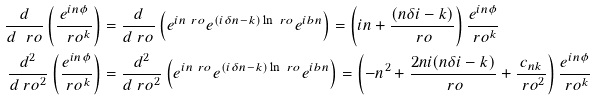Convert formula to latex. <formula><loc_0><loc_0><loc_500><loc_500>\frac { d } { d \ r o } \left ( \frac { e ^ { i n \phi } } { \ r o ^ { k } } \right ) & = \frac { d } { d \ r o } \left ( e ^ { i n \ r o } e ^ { ( i \delta n - k ) \ln \ r o } e ^ { i b n } \right ) = \left ( i n + \frac { ( n \delta i - k ) } { \ r o } \right ) \frac { e ^ { i n \phi } } { \ r o ^ { k } } \\ \frac { d ^ { 2 } } { d \ r o ^ { 2 } } \left ( \frac { e ^ { i n \phi } } { \ r o ^ { k } } \right ) & = \frac { d ^ { 2 } } { d \ r o ^ { 2 } } \left ( e ^ { i n \ r o } e ^ { ( i \delta n - k ) \ln \ r o } e ^ { i b n } \right ) = \left ( - n ^ { 2 } + \frac { 2 n i ( n \delta i - k ) } { \ r o } + \frac { c _ { n k } } { \ r o ^ { 2 } } \right ) \frac { e ^ { i n \phi } } { \ r o ^ { k } }</formula> 